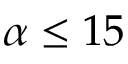Convert formula to latex. <formula><loc_0><loc_0><loc_500><loc_500>\alpha \leq 1 5</formula> 